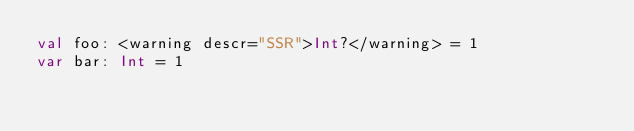<code> <loc_0><loc_0><loc_500><loc_500><_Kotlin_>val foo: <warning descr="SSR">Int?</warning> = 1
var bar: Int = 1</code> 